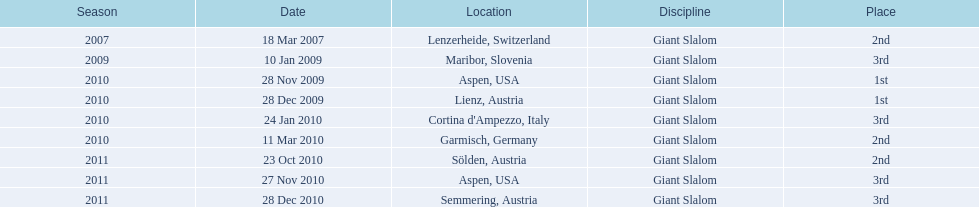What was the finishing place of the last race in december 2010? 3rd. 